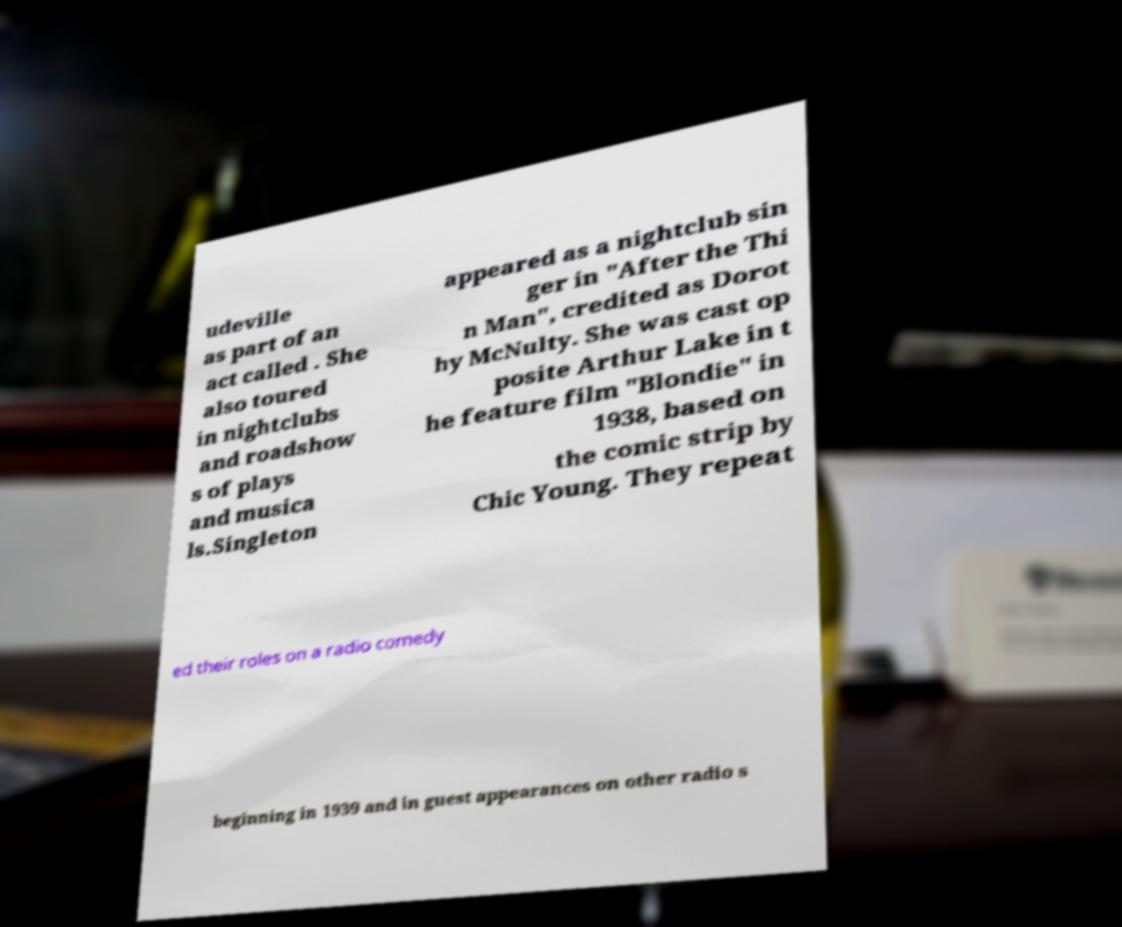I need the written content from this picture converted into text. Can you do that? udeville as part of an act called . She also toured in nightclubs and roadshow s of plays and musica ls.Singleton appeared as a nightclub sin ger in "After the Thi n Man", credited as Dorot hy McNulty. She was cast op posite Arthur Lake in t he feature film "Blondie" in 1938, based on the comic strip by Chic Young. They repeat ed their roles on a radio comedy beginning in 1939 and in guest appearances on other radio s 